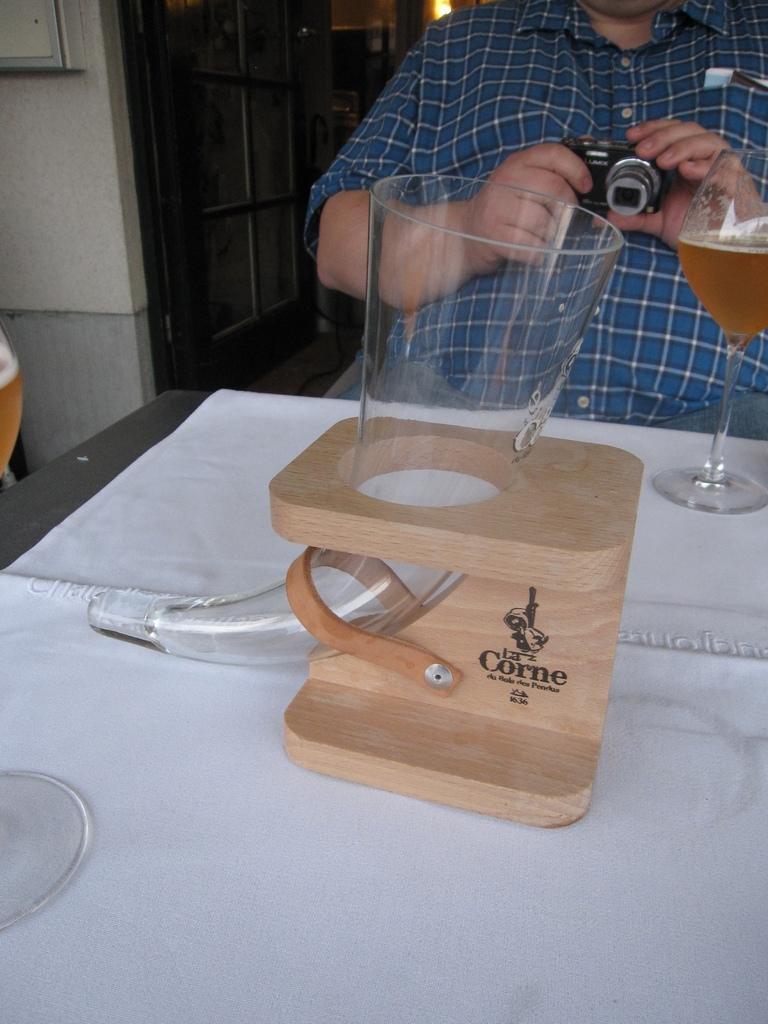Could you give a brief overview of what you see in this image? This image consists of a table and a man who is holding camera, he is on the top right corner. This table has a cloth on it and it has glass on the right side and left side too. There is a door on the back side and light on the top. 